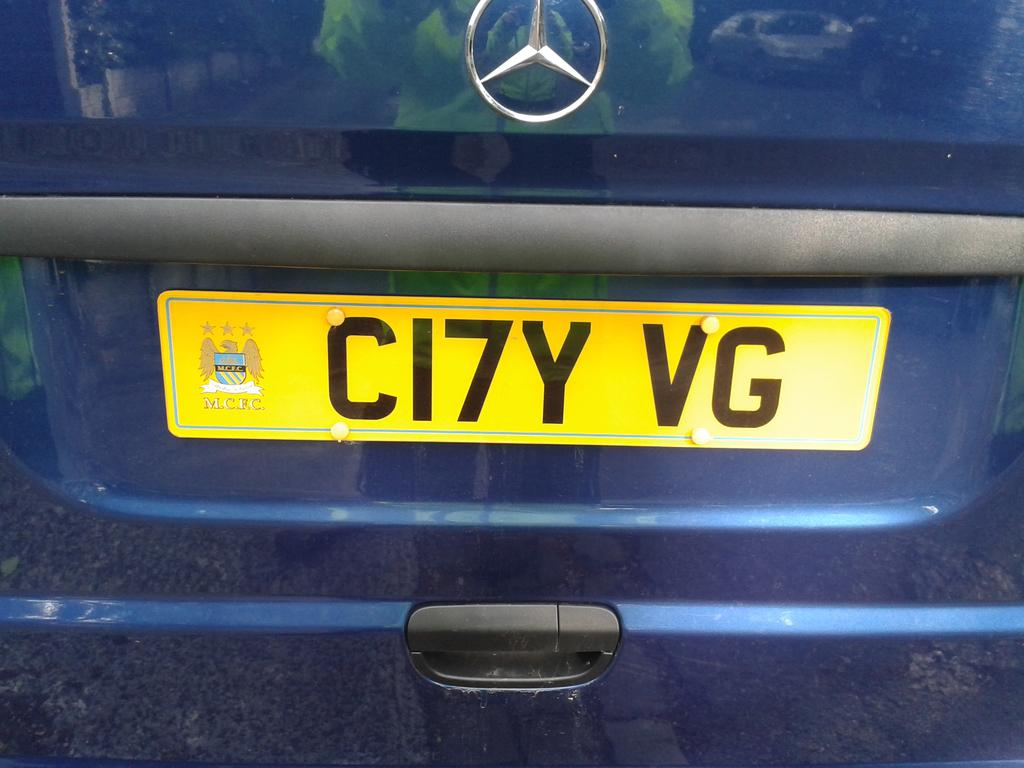<image>
Share a concise interpretation of the image provided. Yellow license plate which says CI7YVG on it. 